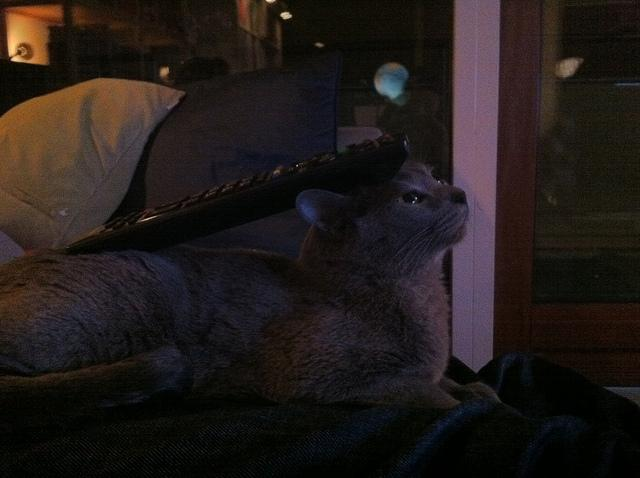What item is the cat balancing on their head? remote 